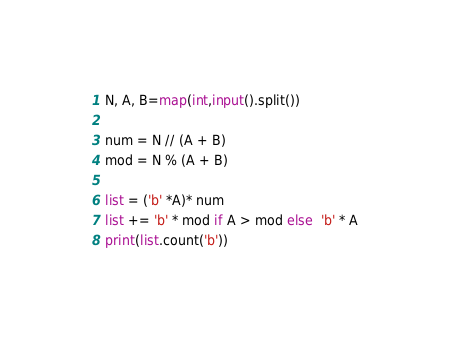<code> <loc_0><loc_0><loc_500><loc_500><_Python_>N, A, B=map(int,input().split())

num = N // (A + B)
mod = N % (A + B)

list = ('b' *A)* num
list += 'b' * mod if A > mod else  'b' * A
print(list.count('b'))</code> 